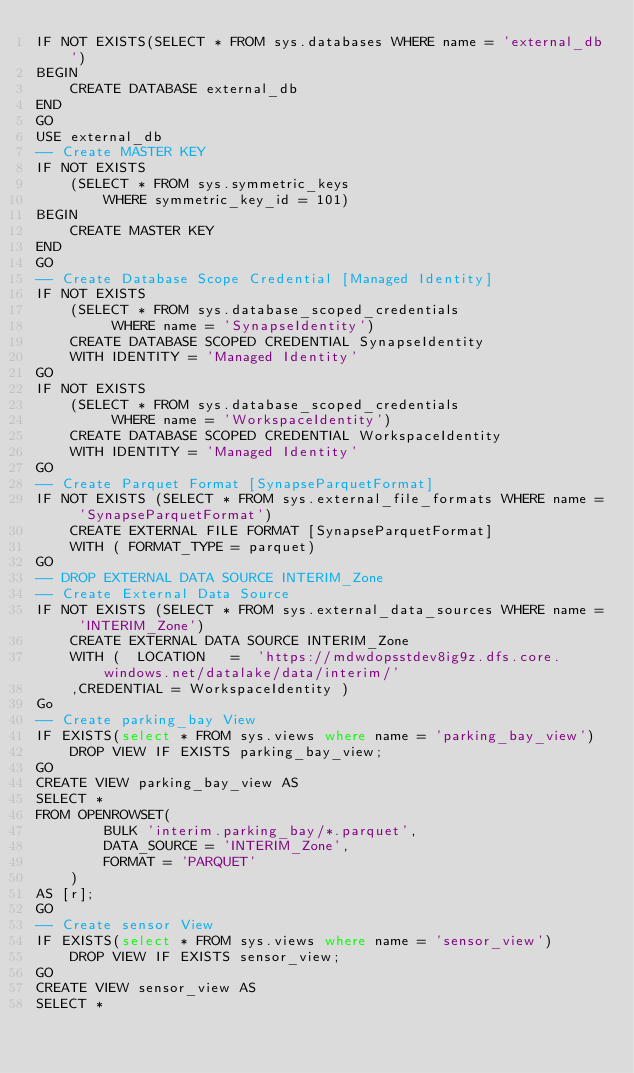<code> <loc_0><loc_0><loc_500><loc_500><_SQL_>IF NOT EXISTS(SELECT * FROM sys.databases WHERE name = 'external_db')
BEGIN
    CREATE DATABASE external_db
END
GO
USE external_db
-- Create MASTER KEY 
IF NOT EXISTS
    (SELECT * FROM sys.symmetric_keys
        WHERE symmetric_key_id = 101)
BEGIN
    CREATE MASTER KEY
END
GO
-- Create Database Scope Credential [Managed Identity]
IF NOT EXISTS
    (SELECT * FROM sys.database_scoped_credentials
         WHERE name = 'SynapseIdentity')
    CREATE DATABASE SCOPED CREDENTIAL SynapseIdentity
    WITH IDENTITY = 'Managed Identity'
GO
IF NOT EXISTS
    (SELECT * FROM sys.database_scoped_credentials
         WHERE name = 'WorkspaceIdentity')
    CREATE DATABASE SCOPED CREDENTIAL WorkspaceIdentity
    WITH IDENTITY = 'Managed Identity'
GO
-- Create Parquet Format [SynapseParquetFormat]
IF NOT EXISTS (SELECT * FROM sys.external_file_formats WHERE name = 'SynapseParquetFormat')
	CREATE EXTERNAL FILE FORMAT [SynapseParquetFormat]
	WITH ( FORMAT_TYPE = parquet)
GO
-- DROP EXTERNAL DATA SOURCE INTERIM_Zone
-- Create External Data Source
IF NOT EXISTS (SELECT * FROM sys.external_data_sources WHERE name = 'INTERIM_Zone')
	CREATE EXTERNAL DATA SOURCE INTERIM_Zone
	WITH (  LOCATION   =  'https://mdwdopsstdev8ig9z.dfs.core.windows.net/datalake/data/interim/'
    ,CREDENTIAL = WorkspaceIdentity )
Go
-- Create parking_bay View 
IF EXISTS(select * FROM sys.views where name = 'parking_bay_view')
    DROP VIEW IF EXISTS parking_bay_view;
GO
CREATE VIEW parking_bay_view AS
SELECT * 
FROM OPENROWSET(
        BULK 'interim.parking_bay/*.parquet',
        DATA_SOURCE = 'INTERIM_Zone',
        FORMAT = 'PARQUET'
    )
AS [r];
GO
-- Create sensor View 
IF EXISTS(select * FROM sys.views where name = 'sensor_view')
    DROP VIEW IF EXISTS sensor_view;
GO
CREATE VIEW sensor_view AS
SELECT * </code> 